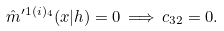Convert formula to latex. <formula><loc_0><loc_0><loc_500><loc_500>\hat { m } ^ { \prime 1 ( i ) _ { 4 } } ( x | h ) = 0 \, \Longrightarrow \, c _ { 3 2 } = 0 .</formula> 